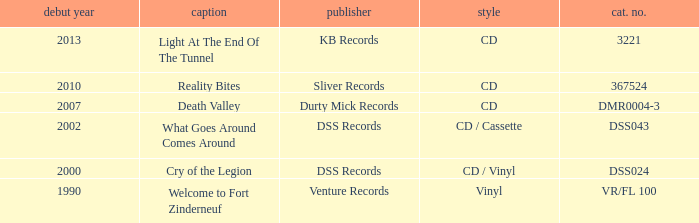What is the latest year of the album with the release title death valley? 2007.0. Could you parse the entire table as a dict? {'header': ['debut year', 'caption', 'publisher', 'style', 'cat. no.'], 'rows': [['2013', 'Light At The End Of The Tunnel', 'KB Records', 'CD', '3221'], ['2010', 'Reality Bites', 'Sliver Records', 'CD', '367524'], ['2007', 'Death Valley', 'Durty Mick Records', 'CD', 'DMR0004-3'], ['2002', 'What Goes Around Comes Around', 'DSS Records', 'CD / Cassette', 'DSS043'], ['2000', 'Cry of the Legion', 'DSS Records', 'CD / Vinyl', 'DSS024'], ['1990', 'Welcome to Fort Zinderneuf', 'Venture Records', 'Vinyl', 'VR/FL 100']]} 